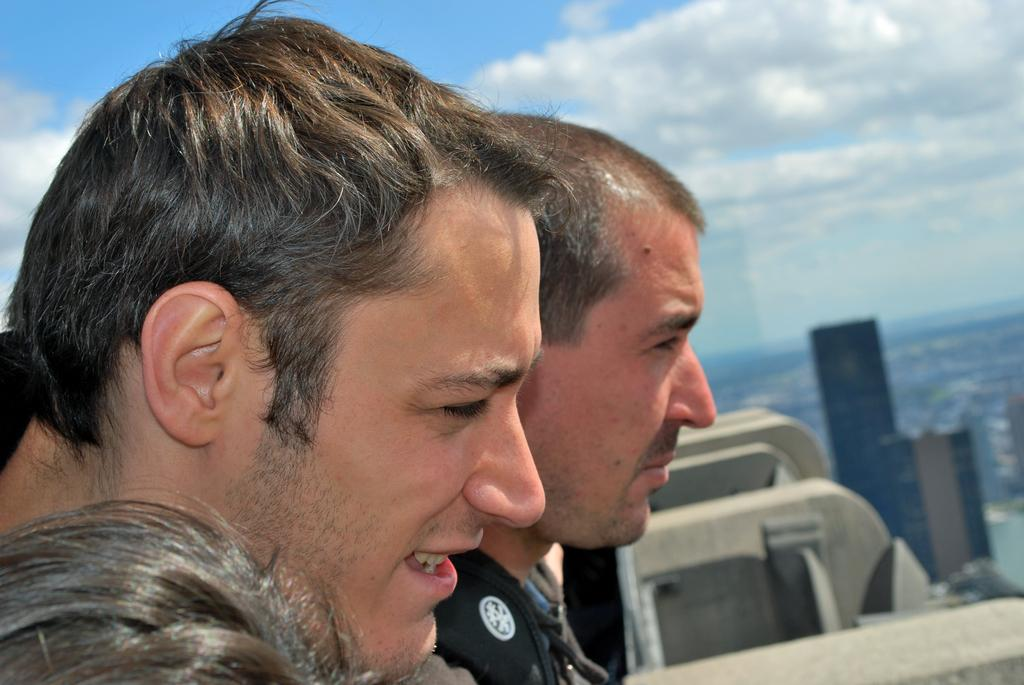Who or what can be seen in the image? There are people in the image. What structures are located on the right side of the image? There are buildings on the right side of the image. What is visible at the top of the image? The sky is visible at the top of the image. What can be observed in the sky? Clouds are present in the sky. What is the name of the dust cloud visible in the image? There is no dust cloud present in the image. 